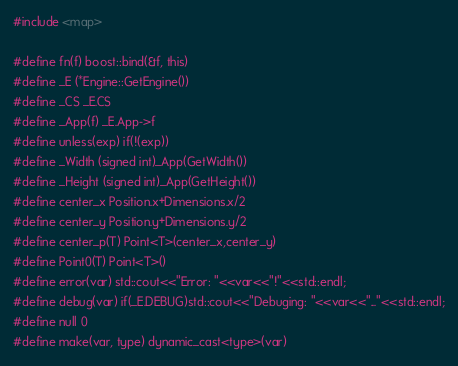<code> <loc_0><loc_0><loc_500><loc_500><_C++_>#include <map>

#define fn(f) boost::bind(&f, this)
#define _E (*Engine::GetEngine())
#define _CS _E.CS
#define _App(f) _E.App->f
#define unless(exp) if(!(exp))
#define _Width (signed int)_App(GetWidth())
#define _Height (signed int)_App(GetHeight())
#define center_x Position.x+Dimensions.x/2
#define center_y Position.y+Dimensions.y/2
#define center_p(T) Point<T>(center_x,center_y)
#define Point0(T) Point<T>()
#define error(var) std::cout<<"Error: "<<var<<"!"<<std::endl;
#define debug(var) if(_E.DEBUG)std::cout<<"Debuging: "<<var<<"..."<<std::endl;
#define null 0
#define make(var, type) dynamic_cast<type>(var)
</code> 